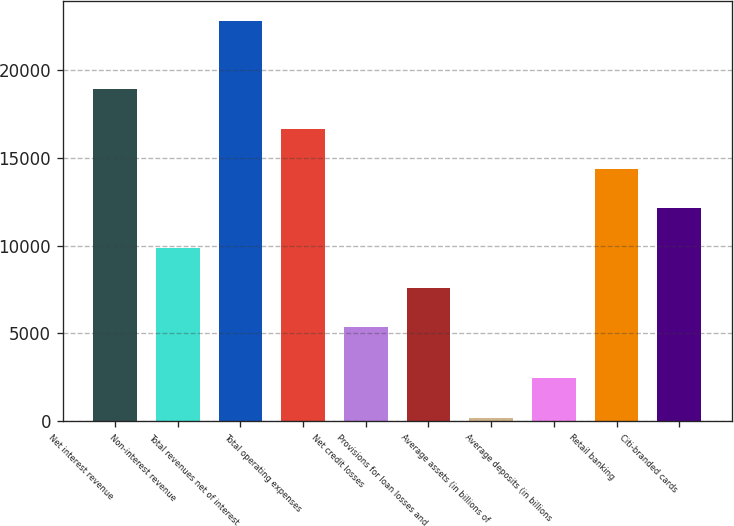Convert chart to OTSL. <chart><loc_0><loc_0><loc_500><loc_500><bar_chart><fcel>Net interest revenue<fcel>Non-interest revenue<fcel>Total revenues net of interest<fcel>Total operating expenses<fcel>Net credit losses<fcel>Provisions for loan losses and<fcel>Average assets (in billions of<fcel>Average deposits (in billions<fcel>Retail banking<fcel>Citi-branded cards<nl><fcel>18901<fcel>9871<fcel>22771<fcel>16643.5<fcel>5356<fcel>7613.5<fcel>196<fcel>2453.5<fcel>14386<fcel>12128.5<nl></chart> 